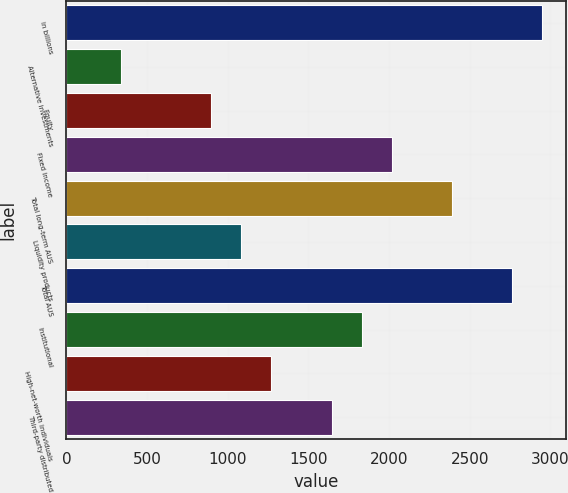Convert chart. <chart><loc_0><loc_0><loc_500><loc_500><bar_chart><fcel>in billions<fcel>Alternative investments<fcel>Equity<fcel>Fixed income<fcel>Total long-term AUS<fcel>Liquidity products<fcel>Total AUS<fcel>Institutional<fcel>High-net-worth individuals<fcel>Third-party distributed<nl><fcel>2951<fcel>338.6<fcel>898.4<fcel>2018<fcel>2391.2<fcel>1085<fcel>2764.4<fcel>1831.4<fcel>1271.6<fcel>1644.8<nl></chart> 